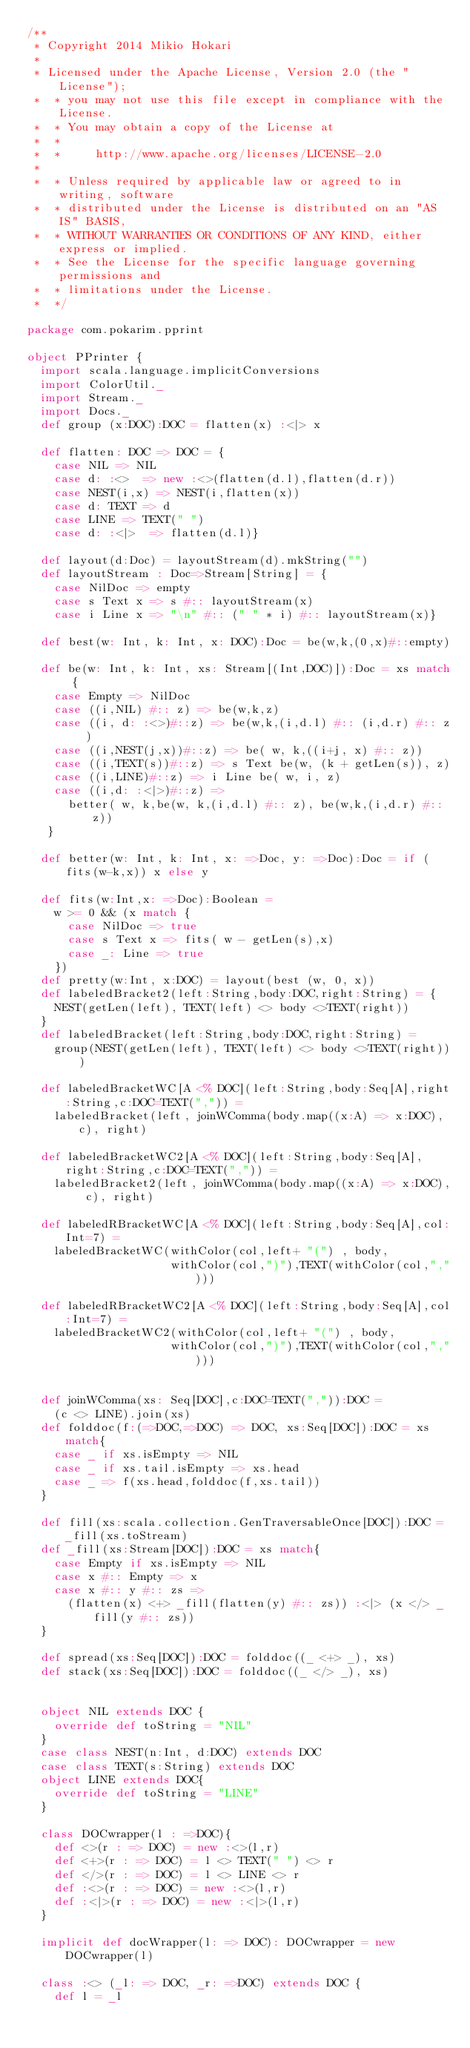Convert code to text. <code><loc_0><loc_0><loc_500><loc_500><_Scala_>/**
 * Copyright 2014 Mikio Hokari
 *
 * Licensed under the Apache License, Version 2.0 (the "License");
 *  * you may not use this file except in compliance with the License.
 *  * You may obtain a copy of the License at
 *  *
 *  *     http://www.apache.org/licenses/LICENSE-2.0
 *
 *  * Unless required by applicable law or agreed to in writing, software
 *  * distributed under the License is distributed on an "AS IS" BASIS,
 *  * WITHOUT WARRANTIES OR CONDITIONS OF ANY KIND, either express or implied.
 *  * See the License for the specific language governing permissions and
 *  * limitations under the License.
 *  */

package com.pokarim.pprint

object PPrinter {
  import scala.language.implicitConversions
  import ColorUtil._
  import Stream._
  import Docs._
  def group (x:DOC):DOC = flatten(x) :<|> x

  def flatten: DOC => DOC = {
	case NIL => NIL
	case d: :<>  => new :<>(flatten(d.l),flatten(d.r))
	case NEST(i,x) => NEST(i,flatten(x))
	case d: TEXT => d
	case LINE => TEXT(" ")
	case d: :<|>  => flatten(d.l)}

  def layout(d:Doc) = layoutStream(d).mkString("")
  def layoutStream : Doc=>Stream[String] = {
	case NilDoc => empty
	case s Text x => s #:: layoutStream(x)
	case i Line x => "\n" #:: (" " * i) #:: layoutStream(x)}
  
  def best(w: Int, k: Int, x: DOC):Doc = be(w,k,(0,x)#::empty)

  def be(w: Int, k: Int, xs: Stream[(Int,DOC)]):Doc = xs match {
   	case Empty => NilDoc
   	case ((i,NIL) #:: z) => be(w,k,z)
   	case ((i, d: :<>)#::z) => be(w,k,(i,d.l) #:: (i,d.r) #:: z )
   	case ((i,NEST(j,x))#::z) => be( w, k,((i+j, x) #:: z))
   	case ((i,TEXT(s))#::z) => s Text be(w, (k + getLen(s)), z)
   	case ((i,LINE)#::z) => i Line be( w, i, z)
   	case ((i,d: :<|>)#::z) => 
   	  better( w, k,be(w, k,(i,d.l) #:: z), be(w,k,(i,d.r) #:: z))
   }
  
  def better(w: Int, k: Int, x: =>Doc, y: =>Doc):Doc = if (fits(w-k,x)) x else y

  def fits(w:Int,x: =>Doc):Boolean = 
	w >= 0 && (x match {
	  case NilDoc => true
	  case s Text x => fits( w - getLen(s),x)
	  case _: Line => true
	})
  def pretty(w:Int, x:DOC) = layout(best (w, 0, x))
  def labeledBracket2(left:String,body:DOC,right:String) = {
	NEST(getLen(left), TEXT(left) <> body <>TEXT(right))
  }
  def labeledBracket(left:String,body:DOC,right:String) = 
	group(NEST(getLen(left), TEXT(left) <> body <>TEXT(right)))

  def labeledBracketWC[A <% DOC](left:String,body:Seq[A],right:String,c:DOC=TEXT(",")) =
	labeledBracket(left, joinWComma(body.map((x:A) => x:DOC), c), right)

  def labeledBracketWC2[A <% DOC](left:String,body:Seq[A],right:String,c:DOC=TEXT(",")) =
	labeledBracket2(left, joinWComma(body.map((x:A) => x:DOC), c), right)

  def labeledRBracketWC[A <% DOC](left:String,body:Seq[A],col:Int=7) =
	labeledBracketWC(withColor(col,left+ "(") , body, 
					 withColor(col,")"),TEXT(withColor(col,",")))

  def labeledRBracketWC2[A <% DOC](left:String,body:Seq[A],col:Int=7) =
	labeledBracketWC2(withColor(col,left+ "(") , body, 
					 withColor(col,")"),TEXT(withColor(col,",")))


  def joinWComma(xs: Seq[DOC],c:DOC=TEXT(",")):DOC = 
	(c <> LINE).join(xs)
  def folddoc(f:(=>DOC,=>DOC) => DOC, xs:Seq[DOC]):DOC = xs match{
	case _ if xs.isEmpty => NIL
	case _ if xs.tail.isEmpty => xs.head
	case _ => f(xs.head,folddoc(f,xs.tail))
  }

  def fill(xs:scala.collection.GenTraversableOnce[DOC]):DOC = _fill(xs.toStream)
  def _fill(xs:Stream[DOC]):DOC = xs match{
	case Empty if xs.isEmpty => NIL
	case x #:: Empty => x
	case x #:: y #:: zs => 
	  (flatten(x) <+> _fill(flatten(y) #:: zs)) :<|> (x </> _fill(y #:: zs))
  }
  
  def spread(xs:Seq[DOC]):DOC = folddoc((_ <+> _), xs)
  def stack(xs:Seq[DOC]):DOC = folddoc((_ </> _), xs)

  
  object NIL extends DOC {
	override def toString = "NIL"
  }
  case class NEST(n:Int, d:DOC) extends DOC
  case class TEXT(s:String) extends DOC
  object LINE extends DOC{
	override def toString = "LINE"
  }
  
  class DOCwrapper(l : =>DOC){
    def <>(r : => DOC) = new :<>(l,r)
	def <+>(r : => DOC) = l <> TEXT(" ") <> r
	def </>(r : => DOC) = l <> LINE <> r
    def :<>(r : => DOC) = new :<>(l,r)
    def :<|>(r : => DOC) = new :<|>(l,r)
  }

  implicit def docWrapper(l: => DOC): DOCwrapper = new DOCwrapper(l)

  class :<> (_l: => DOC, _r: =>DOC) extends DOC {
	def l = _l</code> 